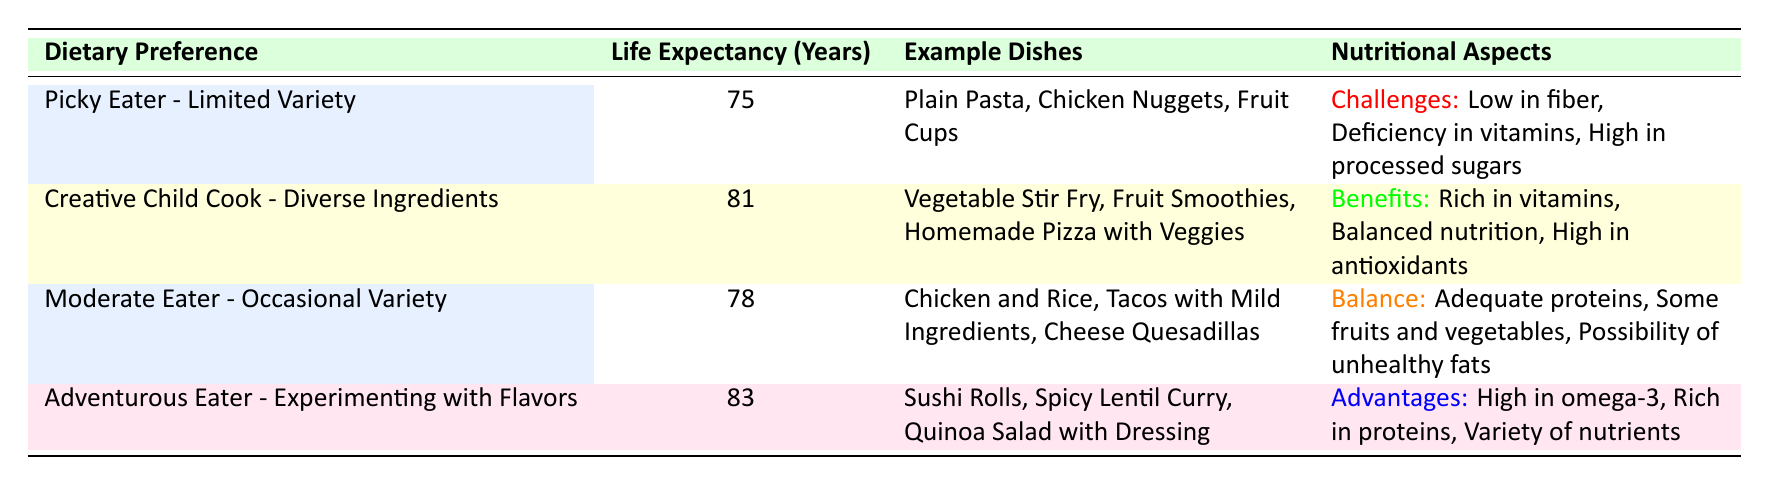What is the life expectancy of a picky eater with limited variety? The table states that a picky eater with limited variety has a life expectancy of 75 years, as shown in the corresponding row under the "Life Expectancy (Years)" column.
Answer: 75 What are some example dishes for a creative child cook? According to the table, the example dishes for a creative child cook are Vegetable Stir Fry, Fruit Smoothies, and Homemade Pizza with Veggies, as listed under "Example Dishes."
Answer: Vegetable Stir Fry, Fruit Smoothies, Homemade Pizza with Veggies Does a moderate eater have any nutritional challenges? The table indicates that a moderate eater has "Adequate proteins" and "Some fruits and vegetables," implying they do not face clear nutritional challenges as indicated for a picky eater. Therefore, the answer is no.
Answer: No What is the average life expectancy of all dietary preferences listed? The life expectancies for the dietary preferences are 75, 81, 78, and 83 years. Summing them gives (75 + 81 + 78 + 83) = 317 years. There are 4 dietary preferences, so the average is 317 / 4 = 79.25 years.
Answer: 79.25 Which dietary preference has the highest life expectancy and what is it? By comparing the life expectancy values: 75, 81, 78, and 83, it is evident that the "Adventurous Eater - Experimenting with Flavors" has the highest life expectancy at 83 years.
Answer: Adventurous Eater - Experimenting with Flavors, 83 What nutritional aspects are associated with the "Adventurous Eater"? The table lists "High in omega-3, Rich in proteins, Variety of nutrients" as nutritional advantages for the "Adventurous Eater," as shown under the "Nutritional Aspects" column.
Answer: High in omega-3, Rich in proteins, Variety of nutrients Is there a notable difference in life expectancy between the picky eater and the creative child cook? The picky eater has a life expectancy of 75 years, while the creative child cook has an expectancy of 81 years, which indicates a difference of 6 years. This difference suggests a significant impact of dietary choices on life expectancy.
Answer: Yes, the difference is 6 years Which dietary preference shows the greatest nutritional benefits? The "Creative Child Cook - Diverse Ingredients" shows the greatest nutritional benefits with "Rich in vitamins, Balanced nutrition, High in antioxidants," compared to the others that have more limitations or challenges.
Answer: Creative Child Cook - Diverse Ingredients How does the life expectancy of a creative child cook compare to that of a moderate eater? The life expectancy of a creative child cook is 81 years, while that of a moderate eater is 78 years. This comparison shows that the creative child cook lives about 3 years longer than the moderate eater.
Answer: 3 years longer 